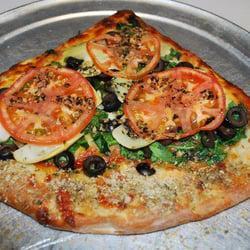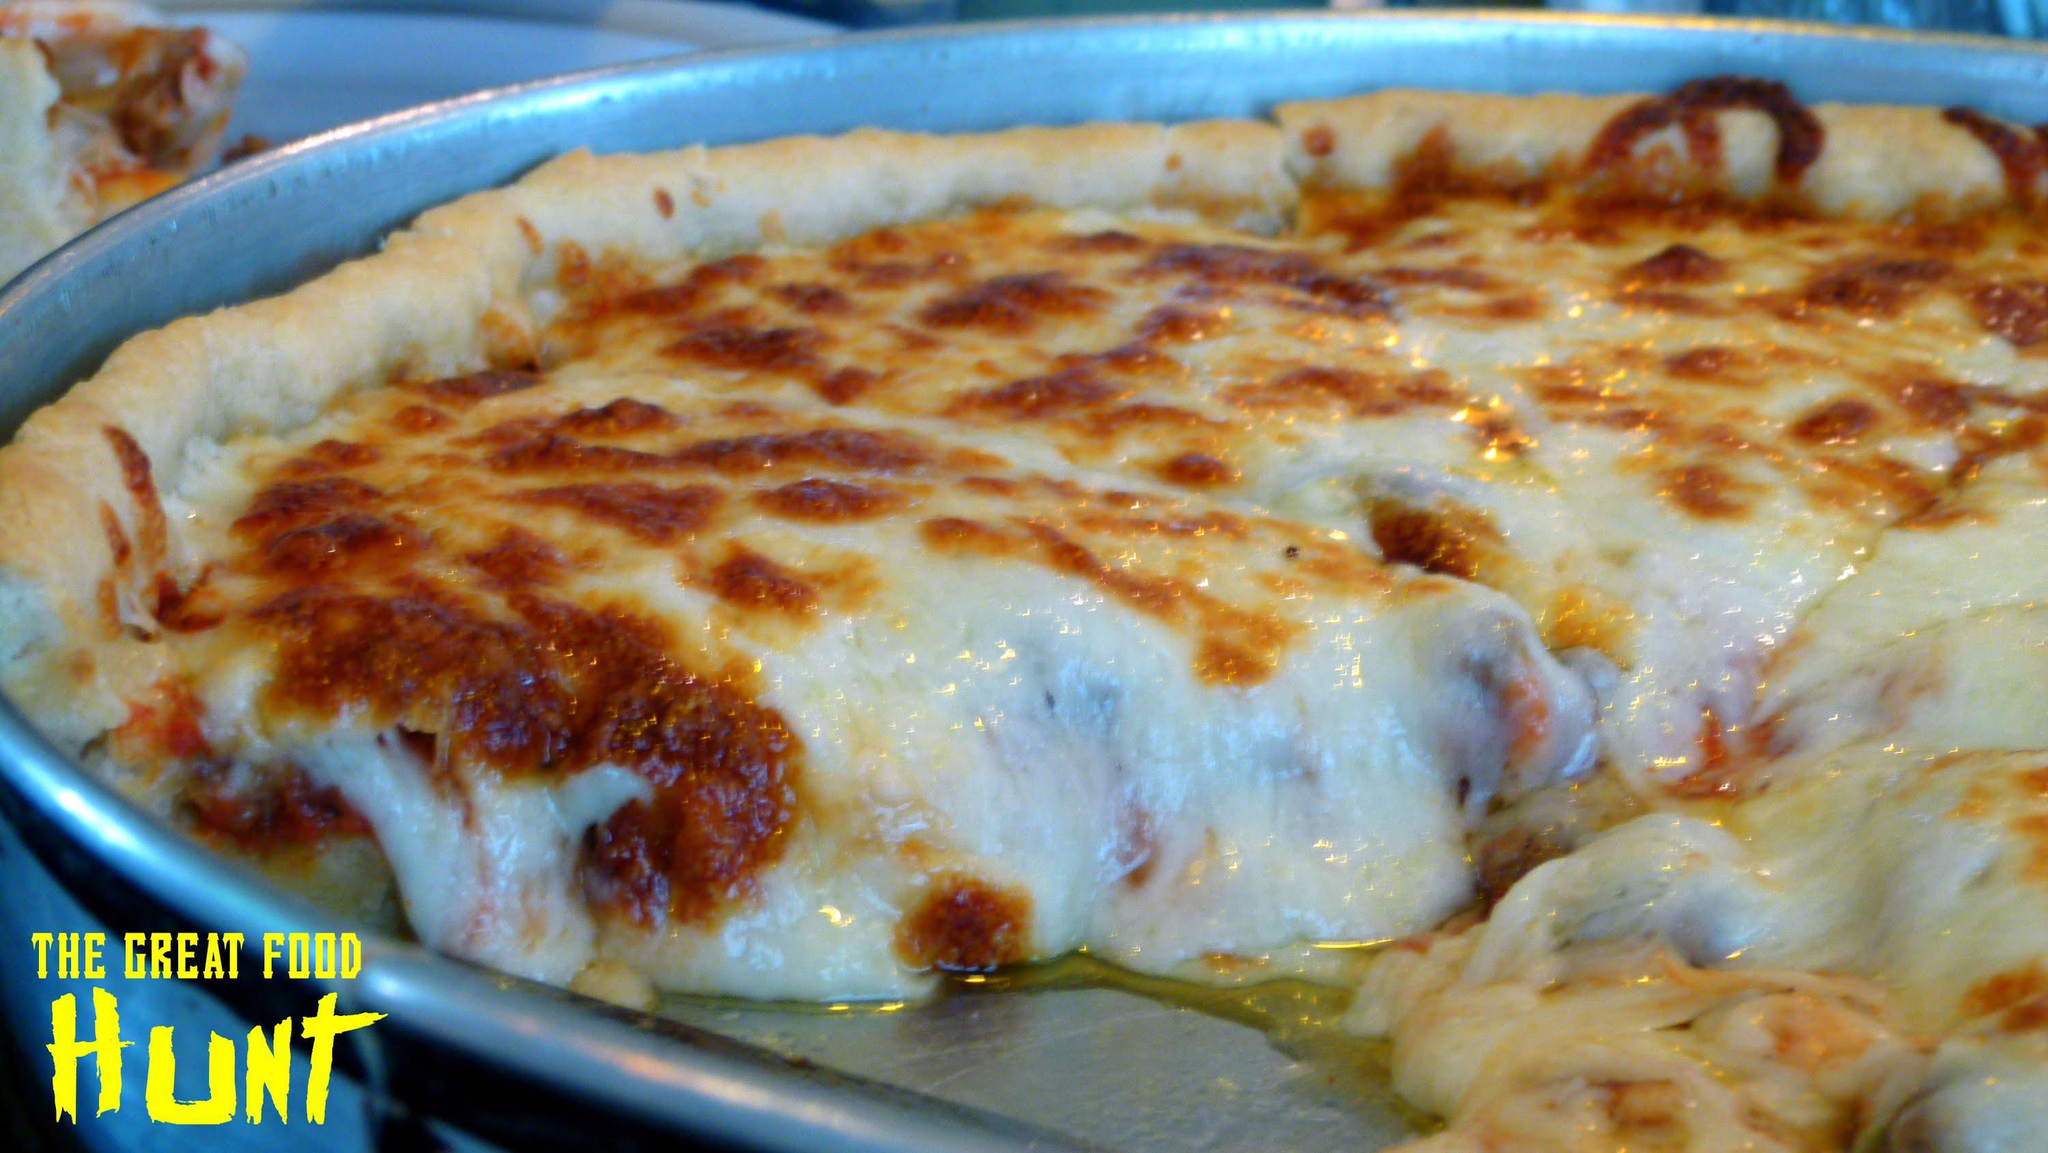The first image is the image on the left, the second image is the image on the right. For the images shown, is this caption "In at least one image there is a single slice of pizza on a sliver pizza tray." true? Answer yes or no. Yes. 